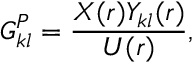Convert formula to latex. <formula><loc_0><loc_0><loc_500><loc_500>G _ { k l } ^ { P } = \frac { X ( r ) Y _ { k l } ( r ) } { U ( r ) } ,</formula> 